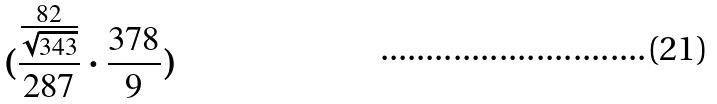Convert formula to latex. <formula><loc_0><loc_0><loc_500><loc_500>( \frac { \frac { 8 2 } { \sqrt { 3 4 3 } } } { 2 8 7 } \cdot \frac { 3 7 8 } { 9 } )</formula> 